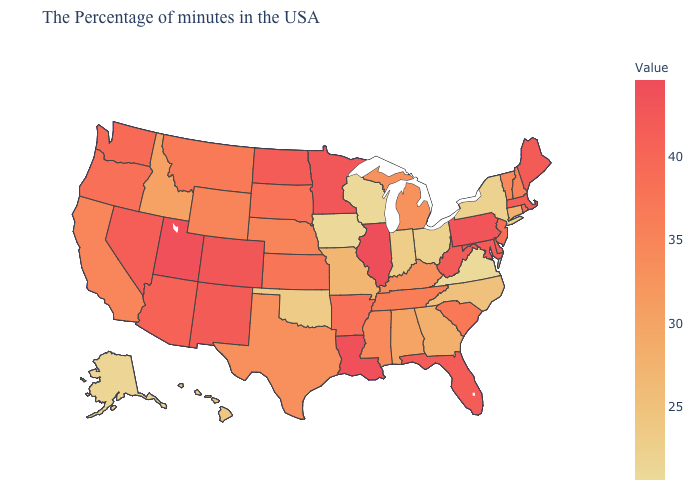Which states have the lowest value in the USA?
Be succinct. Virginia. Does the map have missing data?
Quick response, please. No. Does Nevada have the lowest value in the West?
Answer briefly. No. 